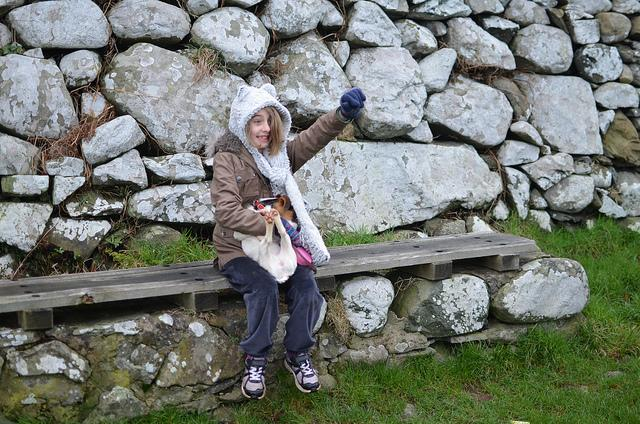What is it called when walls are built without mortar?

Choices:
A) dry stone
B) rubble
C) neolithic
D) stack dry stone 